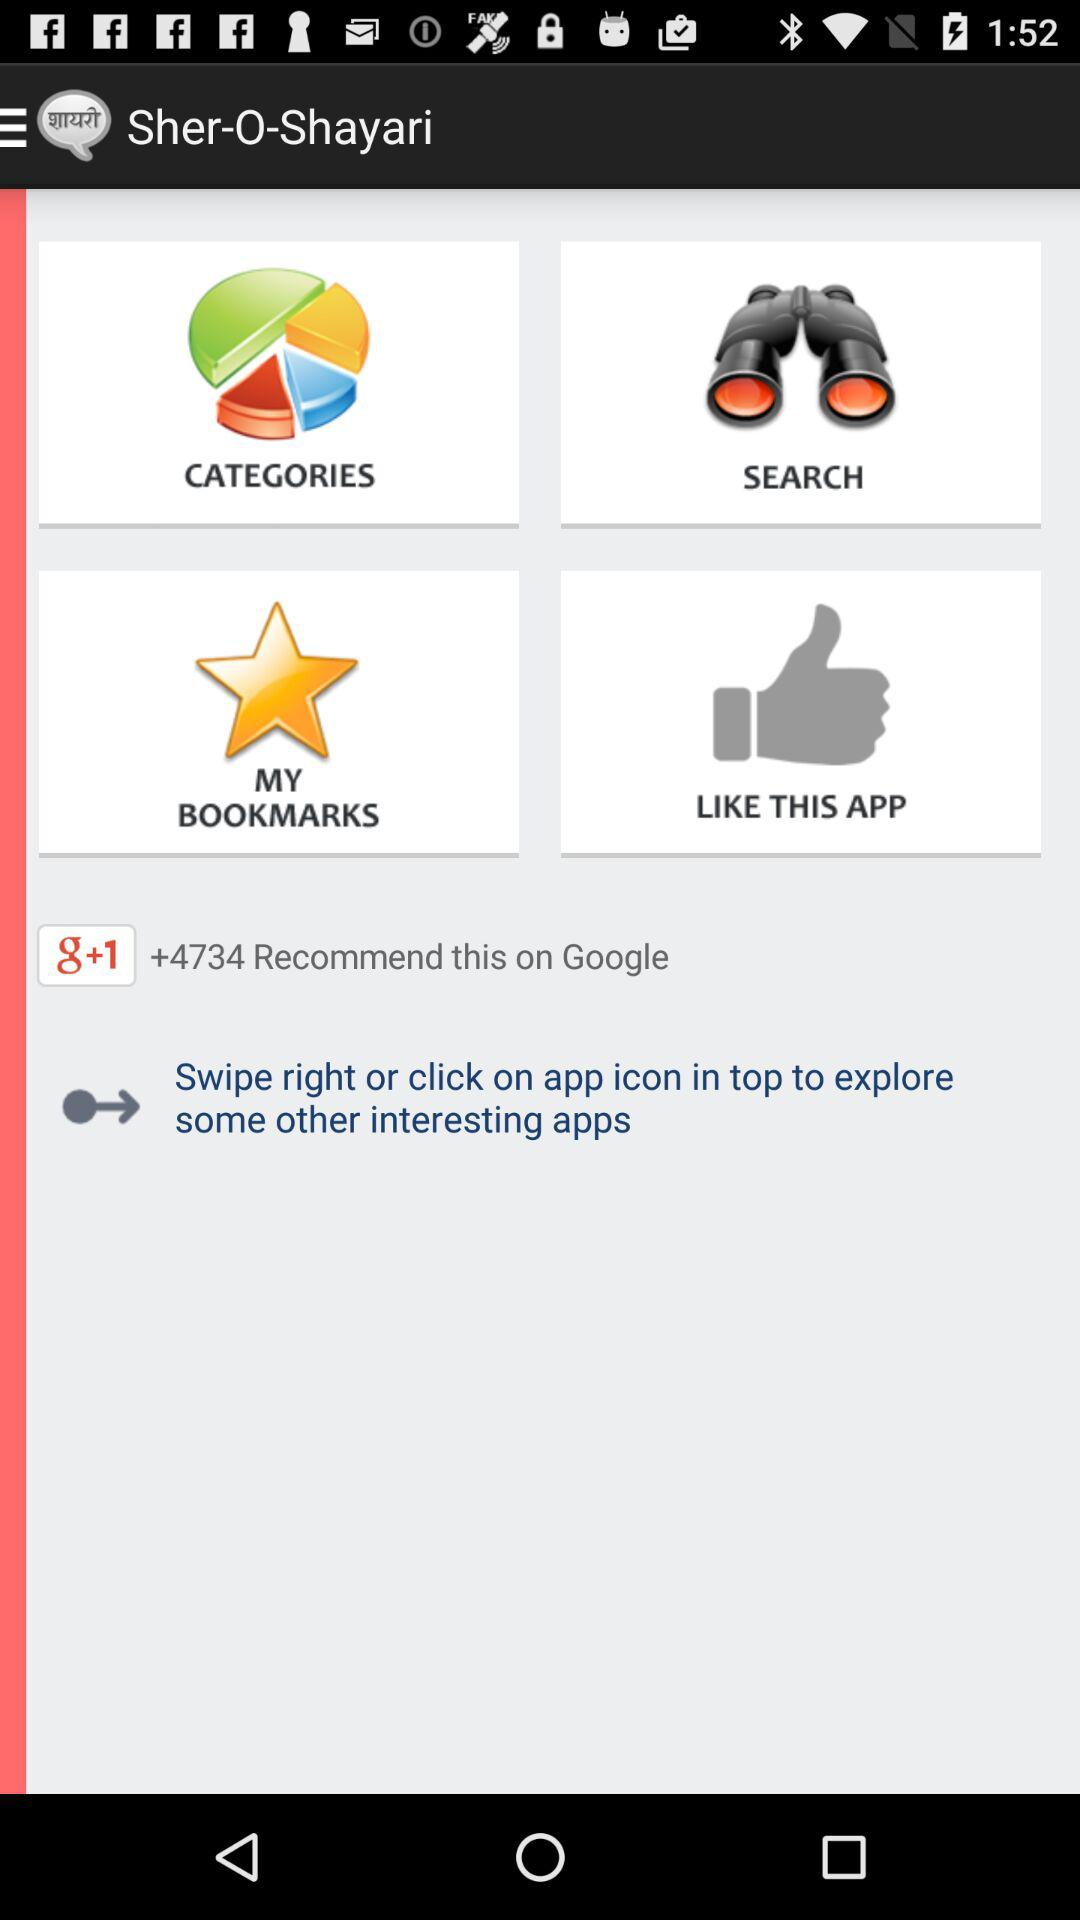How many people recommend this application on Google Plus? There are +4734 people who recommended this application. 